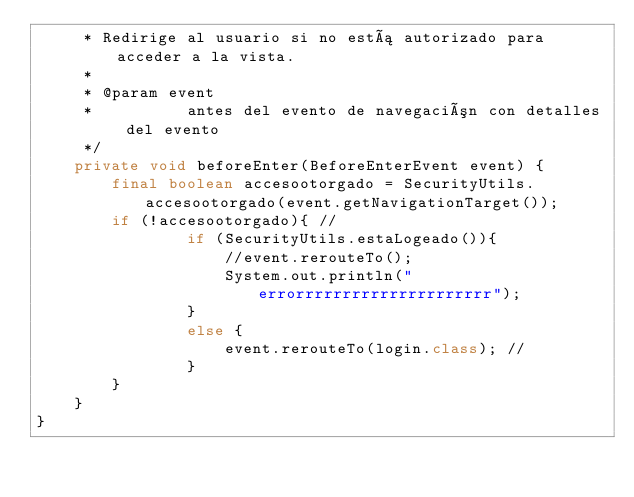Convert code to text. <code><loc_0><loc_0><loc_500><loc_500><_Java_>     * Redirige al usuario si no está autorizado para acceder a la vista.
     *
     * @param event
     *          antes del evento de navegación con detalles del evento
     */
    private void beforeEnter(BeforeEnterEvent event) {
        final boolean accesootorgado = SecurityUtils.accesootorgado(event.getNavigationTarget());
        if (!accesootorgado){ //
                if (SecurityUtils.estaLogeado()){
                    //event.rerouteTo();
                    System.out.println("errorrrrrrrrrrrrrrrrrrrrr");
                }
                else {
                    event.rerouteTo(login.class); //
                }
        }
    }
}
</code> 